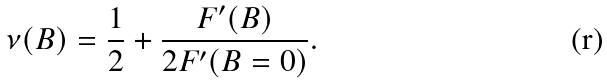<formula> <loc_0><loc_0><loc_500><loc_500>\nu ( B ) = \frac { 1 } { 2 } + \frac { F ^ { \prime } ( B ) } { 2 F ^ { \prime } ( B = 0 ) } .</formula> 